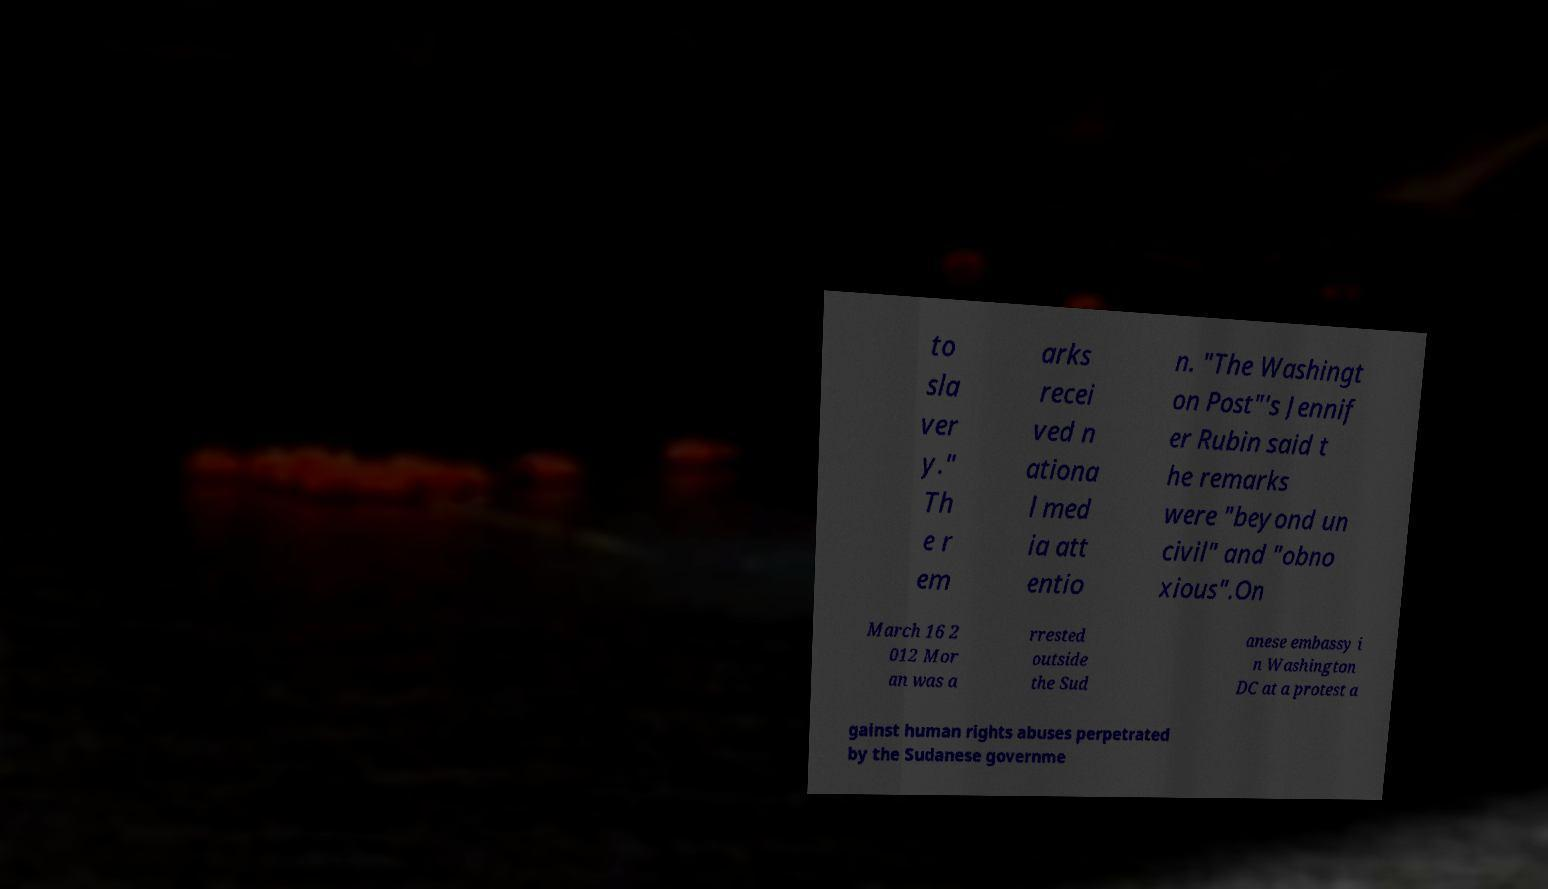Can you accurately transcribe the text from the provided image for me? to sla ver y." Th e r em arks recei ved n ationa l med ia att entio n. "The Washingt on Post"'s Jennif er Rubin said t he remarks were "beyond un civil" and "obno xious".On March 16 2 012 Mor an was a rrested outside the Sud anese embassy i n Washington DC at a protest a gainst human rights abuses perpetrated by the Sudanese governme 